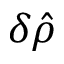<formula> <loc_0><loc_0><loc_500><loc_500>\delta \hat { \rho }</formula> 